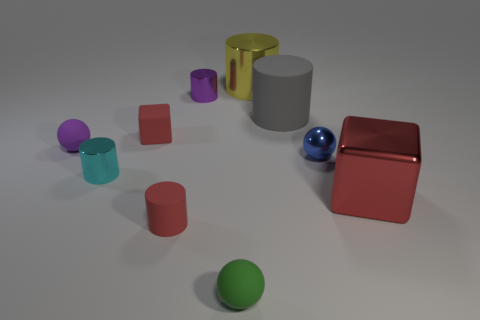Subtract 1 cylinders. How many cylinders are left? 4 Subtract all purple shiny cylinders. How many cylinders are left? 4 Subtract all brown cylinders. Subtract all green spheres. How many cylinders are left? 5 Subtract all spheres. How many objects are left? 7 Add 7 small rubber balls. How many small rubber balls are left? 9 Add 5 brown rubber cubes. How many brown rubber cubes exist? 5 Subtract 0 yellow balls. How many objects are left? 10 Subtract all small blue balls. Subtract all brown matte cylinders. How many objects are left? 9 